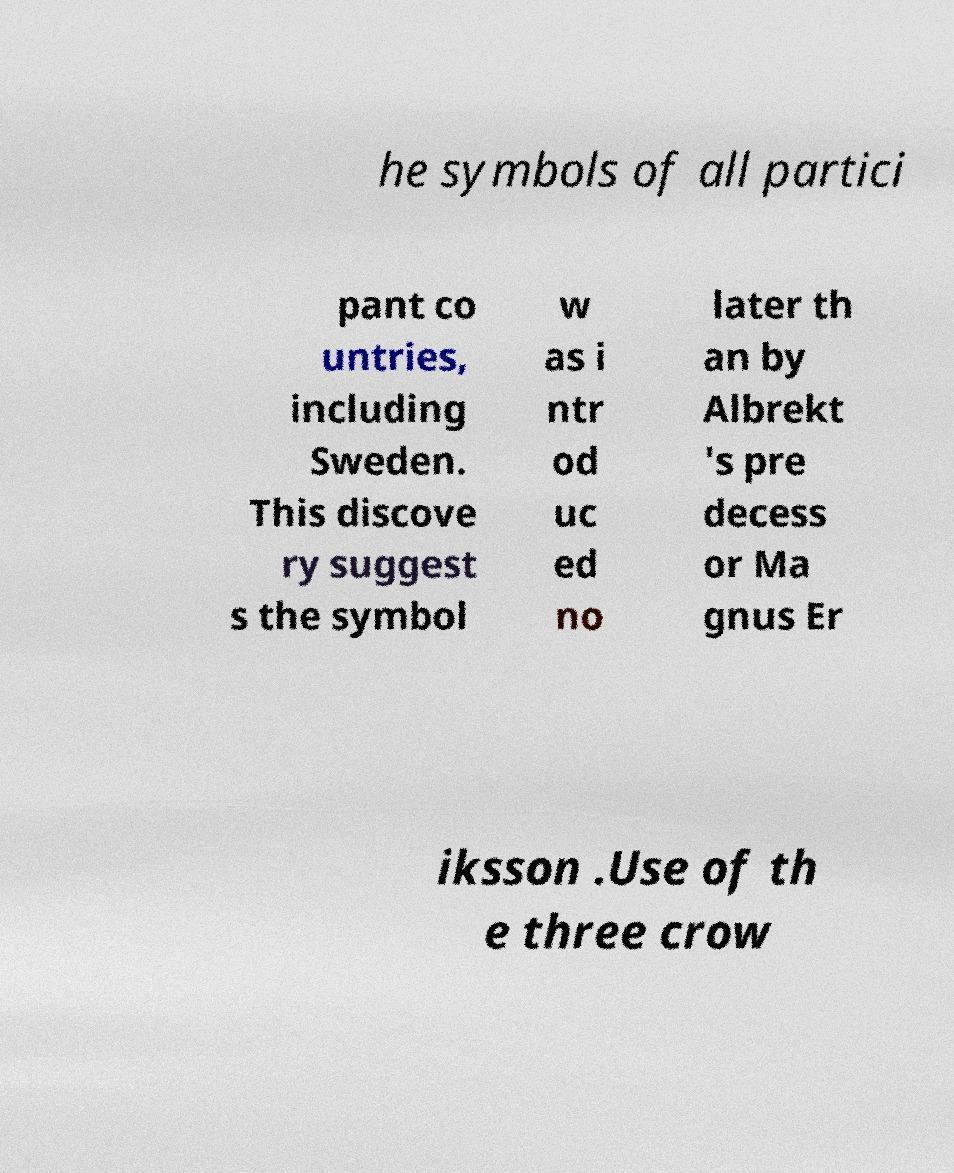Could you assist in decoding the text presented in this image and type it out clearly? he symbols of all partici pant co untries, including Sweden. This discove ry suggest s the symbol w as i ntr od uc ed no later th an by Albrekt 's pre decess or Ma gnus Er iksson .Use of th e three crow 